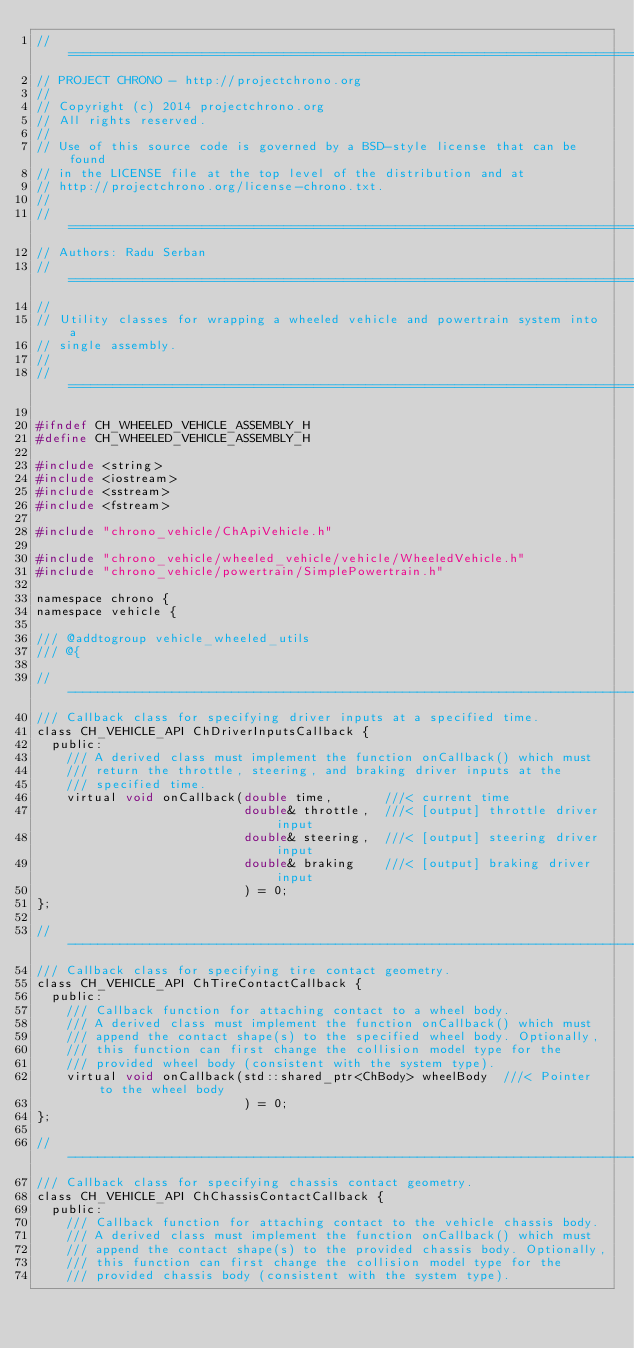Convert code to text. <code><loc_0><loc_0><loc_500><loc_500><_C_>// =============================================================================
// PROJECT CHRONO - http://projectchrono.org
//
// Copyright (c) 2014 projectchrono.org
// All rights reserved.
//
// Use of this source code is governed by a BSD-style license that can be found
// in the LICENSE file at the top level of the distribution and at
// http://projectchrono.org/license-chrono.txt.
//
// =============================================================================
// Authors: Radu Serban
// =============================================================================
//
// Utility classes for wrapping a wheeled vehicle and powertrain system into a
// single assembly.
//
// =============================================================================

#ifndef CH_WHEELED_VEHICLE_ASSEMBLY_H
#define CH_WHEELED_VEHICLE_ASSEMBLY_H

#include <string>
#include <iostream>
#include <sstream>
#include <fstream>

#include "chrono_vehicle/ChApiVehicle.h"

#include "chrono_vehicle/wheeled_vehicle/vehicle/WheeledVehicle.h"
#include "chrono_vehicle/powertrain/SimplePowertrain.h"

namespace chrono {
namespace vehicle {

/// @addtogroup vehicle_wheeled_utils
/// @{

// -----------------------------------------------------------------------------
/// Callback class for specifying driver inputs at a specified time.
class CH_VEHICLE_API ChDriverInputsCallback {
  public:
    /// A derived class must implement the function onCallback() which must
    /// return the throttle, steering, and braking driver inputs at the
    /// specified time.
    virtual void onCallback(double time,       ///< current time
                            double& throttle,  ///< [output] throttle driver input
                            double& steering,  ///< [output] steering driver input
                            double& braking    ///< [output] braking driver input
                            ) = 0;
};

// -----------------------------------------------------------------------------
/// Callback class for specifying tire contact geometry.
class CH_VEHICLE_API ChTireContactCallback {
  public:
    /// Callback function for attaching contact to a wheel body.
    /// A derived class must implement the function onCallback() which must
    /// append the contact shape(s) to the specified wheel body. Optionally,
    /// this function can first change the collision model type for the
    /// provided wheel body (consistent with the system type).
    virtual void onCallback(std::shared_ptr<ChBody> wheelBody  ///< Pointer to the wheel body
                            ) = 0;
};

// -----------------------------------------------------------------------------
/// Callback class for specifying chassis contact geometry.
class CH_VEHICLE_API ChChassisContactCallback {
  public:
    /// Callback function for attaching contact to the vehicle chassis body.
    /// A derived class must implement the function onCallback() which must
    /// append the contact shape(s) to the provided chassis body. Optionally,
    /// this function can first change the collision model type for the
    /// provided chassis body (consistent with the system type).</code> 